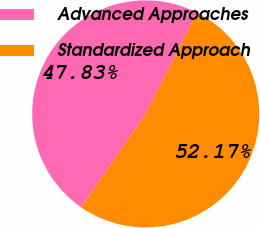Convert chart. <chart><loc_0><loc_0><loc_500><loc_500><pie_chart><fcel>Advanced Approaches<fcel>Standardized Approach<nl><fcel>47.83%<fcel>52.17%<nl></chart> 